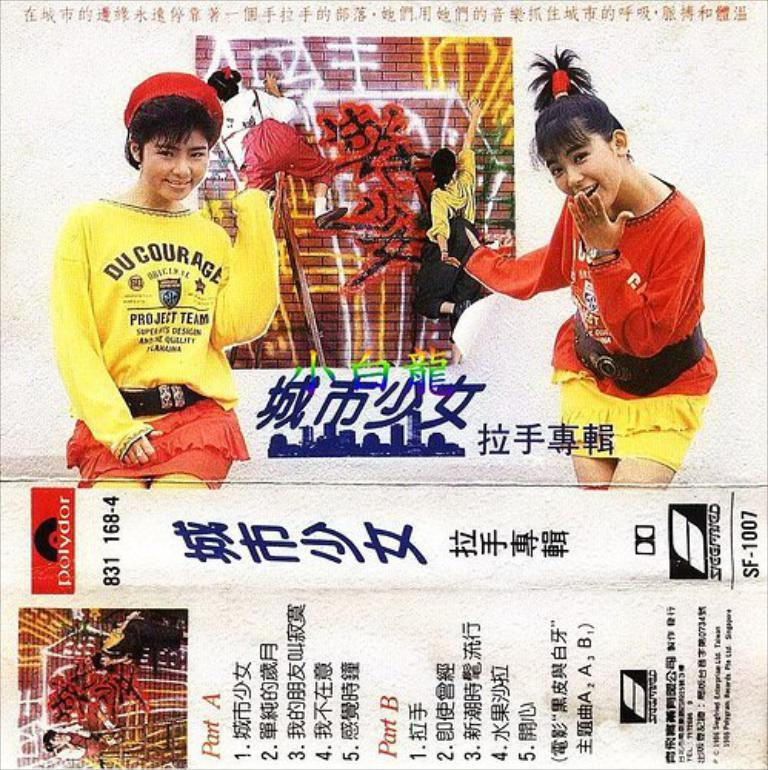How many posters are visible in the image? There are two posters in the image. What can be found on the posters? The posters have numbers and words on them, as well as a photo of two persons standing and smiling. What is the content of the photo on the posters? The photo on the posters shows two persons standing and smiling. Can you see a woman walking by the lake in the image? There is no woman or lake present in the image; it only features two posters with numbers, words, and a photo of two persons. 